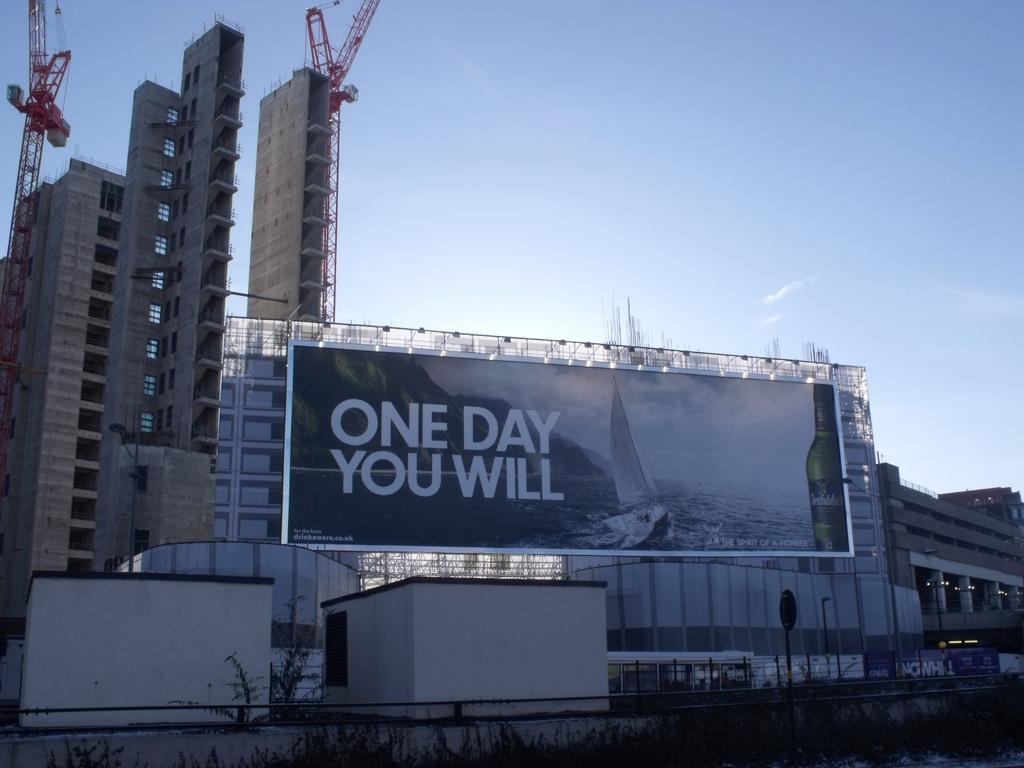Describe this image in one or two sentences. In this image I can see there are buildings and a fence. And there is a banner with text. And there are grass and rooms. And there is a tree. And there is a pole and a wall. And at the top there is a sky. 